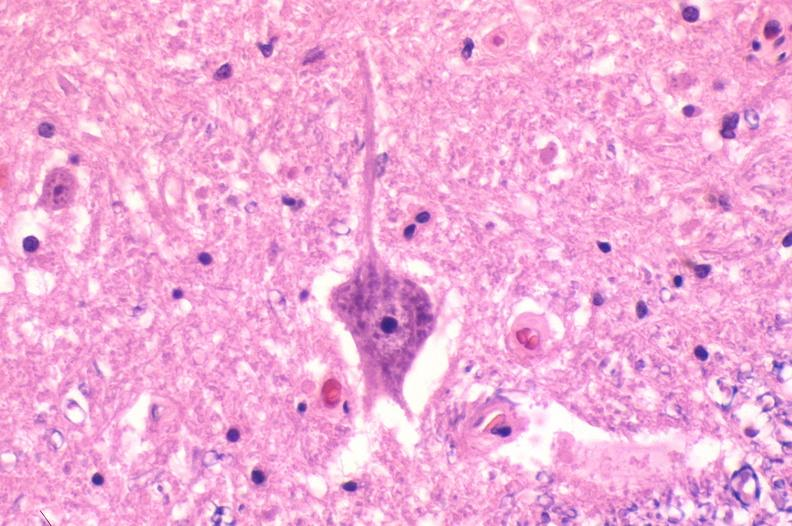does traumatic rupture show spinal cord injury due to vertebral column trauma, demyelination?
Answer the question using a single word or phrase. No 